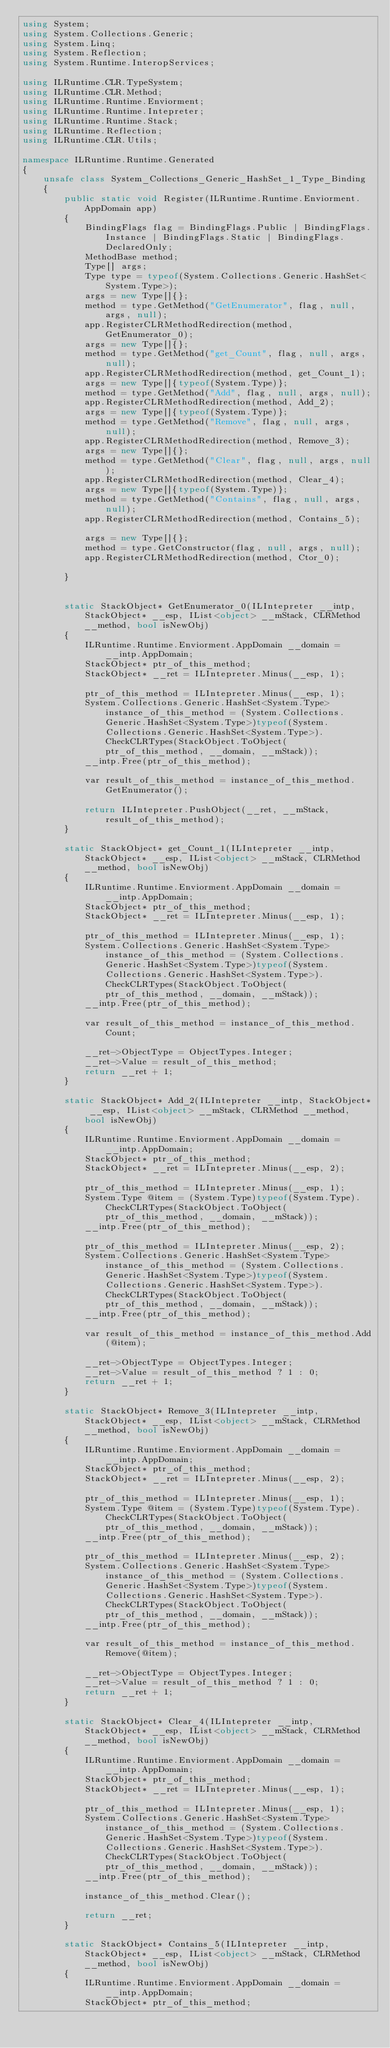Convert code to text. <code><loc_0><loc_0><loc_500><loc_500><_C#_>using System;
using System.Collections.Generic;
using System.Linq;
using System.Reflection;
using System.Runtime.InteropServices;

using ILRuntime.CLR.TypeSystem;
using ILRuntime.CLR.Method;
using ILRuntime.Runtime.Enviorment;
using ILRuntime.Runtime.Intepreter;
using ILRuntime.Runtime.Stack;
using ILRuntime.Reflection;
using ILRuntime.CLR.Utils;

namespace ILRuntime.Runtime.Generated
{
    unsafe class System_Collections_Generic_HashSet_1_Type_Binding
    {
        public static void Register(ILRuntime.Runtime.Enviorment.AppDomain app)
        {
            BindingFlags flag = BindingFlags.Public | BindingFlags.Instance | BindingFlags.Static | BindingFlags.DeclaredOnly;
            MethodBase method;
            Type[] args;
            Type type = typeof(System.Collections.Generic.HashSet<System.Type>);
            args = new Type[]{};
            method = type.GetMethod("GetEnumerator", flag, null, args, null);
            app.RegisterCLRMethodRedirection(method, GetEnumerator_0);
            args = new Type[]{};
            method = type.GetMethod("get_Count", flag, null, args, null);
            app.RegisterCLRMethodRedirection(method, get_Count_1);
            args = new Type[]{typeof(System.Type)};
            method = type.GetMethod("Add", flag, null, args, null);
            app.RegisterCLRMethodRedirection(method, Add_2);
            args = new Type[]{typeof(System.Type)};
            method = type.GetMethod("Remove", flag, null, args, null);
            app.RegisterCLRMethodRedirection(method, Remove_3);
            args = new Type[]{};
            method = type.GetMethod("Clear", flag, null, args, null);
            app.RegisterCLRMethodRedirection(method, Clear_4);
            args = new Type[]{typeof(System.Type)};
            method = type.GetMethod("Contains", flag, null, args, null);
            app.RegisterCLRMethodRedirection(method, Contains_5);

            args = new Type[]{};
            method = type.GetConstructor(flag, null, args, null);
            app.RegisterCLRMethodRedirection(method, Ctor_0);

        }


        static StackObject* GetEnumerator_0(ILIntepreter __intp, StackObject* __esp, IList<object> __mStack, CLRMethod __method, bool isNewObj)
        {
            ILRuntime.Runtime.Enviorment.AppDomain __domain = __intp.AppDomain;
            StackObject* ptr_of_this_method;
            StackObject* __ret = ILIntepreter.Minus(__esp, 1);

            ptr_of_this_method = ILIntepreter.Minus(__esp, 1);
            System.Collections.Generic.HashSet<System.Type> instance_of_this_method = (System.Collections.Generic.HashSet<System.Type>)typeof(System.Collections.Generic.HashSet<System.Type>).CheckCLRTypes(StackObject.ToObject(ptr_of_this_method, __domain, __mStack));
            __intp.Free(ptr_of_this_method);

            var result_of_this_method = instance_of_this_method.GetEnumerator();

            return ILIntepreter.PushObject(__ret, __mStack, result_of_this_method);
        }

        static StackObject* get_Count_1(ILIntepreter __intp, StackObject* __esp, IList<object> __mStack, CLRMethod __method, bool isNewObj)
        {
            ILRuntime.Runtime.Enviorment.AppDomain __domain = __intp.AppDomain;
            StackObject* ptr_of_this_method;
            StackObject* __ret = ILIntepreter.Minus(__esp, 1);

            ptr_of_this_method = ILIntepreter.Minus(__esp, 1);
            System.Collections.Generic.HashSet<System.Type> instance_of_this_method = (System.Collections.Generic.HashSet<System.Type>)typeof(System.Collections.Generic.HashSet<System.Type>).CheckCLRTypes(StackObject.ToObject(ptr_of_this_method, __domain, __mStack));
            __intp.Free(ptr_of_this_method);

            var result_of_this_method = instance_of_this_method.Count;

            __ret->ObjectType = ObjectTypes.Integer;
            __ret->Value = result_of_this_method;
            return __ret + 1;
        }

        static StackObject* Add_2(ILIntepreter __intp, StackObject* __esp, IList<object> __mStack, CLRMethod __method, bool isNewObj)
        {
            ILRuntime.Runtime.Enviorment.AppDomain __domain = __intp.AppDomain;
            StackObject* ptr_of_this_method;
            StackObject* __ret = ILIntepreter.Minus(__esp, 2);

            ptr_of_this_method = ILIntepreter.Minus(__esp, 1);
            System.Type @item = (System.Type)typeof(System.Type).CheckCLRTypes(StackObject.ToObject(ptr_of_this_method, __domain, __mStack));
            __intp.Free(ptr_of_this_method);

            ptr_of_this_method = ILIntepreter.Minus(__esp, 2);
            System.Collections.Generic.HashSet<System.Type> instance_of_this_method = (System.Collections.Generic.HashSet<System.Type>)typeof(System.Collections.Generic.HashSet<System.Type>).CheckCLRTypes(StackObject.ToObject(ptr_of_this_method, __domain, __mStack));
            __intp.Free(ptr_of_this_method);

            var result_of_this_method = instance_of_this_method.Add(@item);

            __ret->ObjectType = ObjectTypes.Integer;
            __ret->Value = result_of_this_method ? 1 : 0;
            return __ret + 1;
        }

        static StackObject* Remove_3(ILIntepreter __intp, StackObject* __esp, IList<object> __mStack, CLRMethod __method, bool isNewObj)
        {
            ILRuntime.Runtime.Enviorment.AppDomain __domain = __intp.AppDomain;
            StackObject* ptr_of_this_method;
            StackObject* __ret = ILIntepreter.Minus(__esp, 2);

            ptr_of_this_method = ILIntepreter.Minus(__esp, 1);
            System.Type @item = (System.Type)typeof(System.Type).CheckCLRTypes(StackObject.ToObject(ptr_of_this_method, __domain, __mStack));
            __intp.Free(ptr_of_this_method);

            ptr_of_this_method = ILIntepreter.Minus(__esp, 2);
            System.Collections.Generic.HashSet<System.Type> instance_of_this_method = (System.Collections.Generic.HashSet<System.Type>)typeof(System.Collections.Generic.HashSet<System.Type>).CheckCLRTypes(StackObject.ToObject(ptr_of_this_method, __domain, __mStack));
            __intp.Free(ptr_of_this_method);

            var result_of_this_method = instance_of_this_method.Remove(@item);

            __ret->ObjectType = ObjectTypes.Integer;
            __ret->Value = result_of_this_method ? 1 : 0;
            return __ret + 1;
        }

        static StackObject* Clear_4(ILIntepreter __intp, StackObject* __esp, IList<object> __mStack, CLRMethod __method, bool isNewObj)
        {
            ILRuntime.Runtime.Enviorment.AppDomain __domain = __intp.AppDomain;
            StackObject* ptr_of_this_method;
            StackObject* __ret = ILIntepreter.Minus(__esp, 1);

            ptr_of_this_method = ILIntepreter.Minus(__esp, 1);
            System.Collections.Generic.HashSet<System.Type> instance_of_this_method = (System.Collections.Generic.HashSet<System.Type>)typeof(System.Collections.Generic.HashSet<System.Type>).CheckCLRTypes(StackObject.ToObject(ptr_of_this_method, __domain, __mStack));
            __intp.Free(ptr_of_this_method);

            instance_of_this_method.Clear();

            return __ret;
        }

        static StackObject* Contains_5(ILIntepreter __intp, StackObject* __esp, IList<object> __mStack, CLRMethod __method, bool isNewObj)
        {
            ILRuntime.Runtime.Enviorment.AppDomain __domain = __intp.AppDomain;
            StackObject* ptr_of_this_method;</code> 